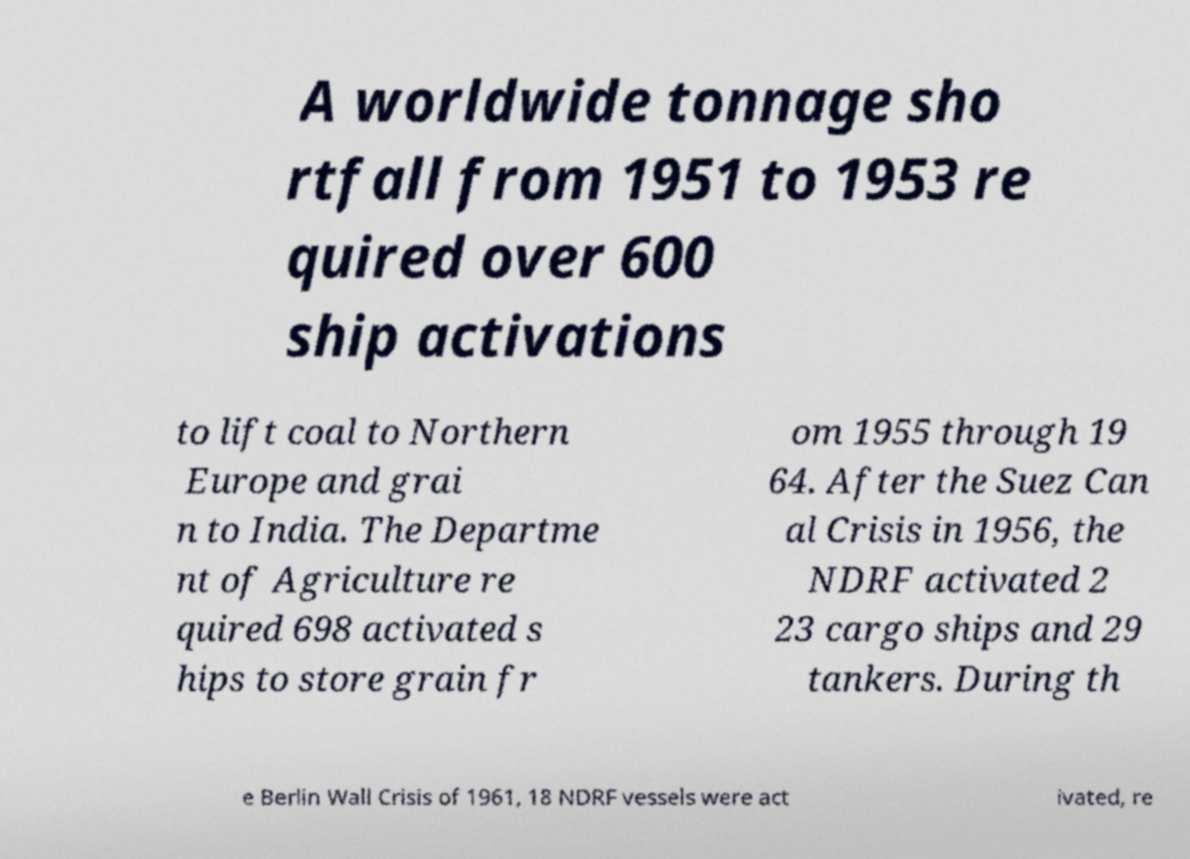What messages or text are displayed in this image? I need them in a readable, typed format. A worldwide tonnage sho rtfall from 1951 to 1953 re quired over 600 ship activations to lift coal to Northern Europe and grai n to India. The Departme nt of Agriculture re quired 698 activated s hips to store grain fr om 1955 through 19 64. After the Suez Can al Crisis in 1956, the NDRF activated 2 23 cargo ships and 29 tankers. During th e Berlin Wall Crisis of 1961, 18 NDRF vessels were act ivated, re 